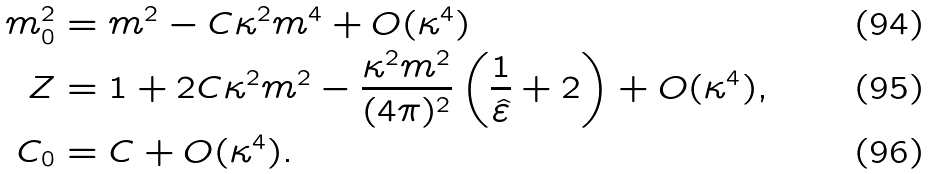Convert formula to latex. <formula><loc_0><loc_0><loc_500><loc_500>m _ { 0 } ^ { 2 } & = m ^ { 2 } - C \kappa ^ { 2 } m ^ { 4 } + O ( \kappa ^ { 4 } ) \\ Z & = 1 + 2 C \kappa ^ { 2 } m ^ { 2 } - \frac { \kappa ^ { 2 } m ^ { 2 } } { ( 4 \pi ) ^ { 2 } } \left ( \frac { 1 } { \hat { \varepsilon } } + 2 \right ) + O ( \kappa ^ { 4 } ) , \\ C _ { 0 } & = C + O ( \kappa ^ { 4 } ) .</formula> 